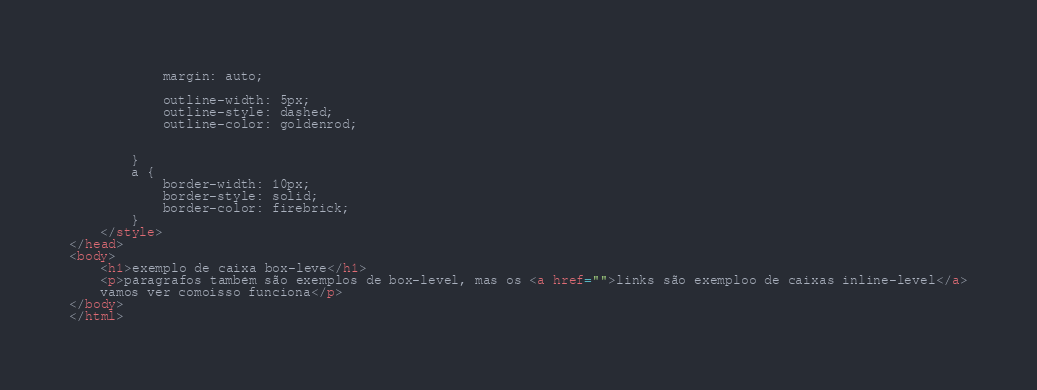Convert code to text. <code><loc_0><loc_0><loc_500><loc_500><_HTML_>            margin: auto;
            
            outline-width: 5px;
            outline-style: dashed;
            outline-color: goldenrod;


        }
        a {
            border-width: 10px;
            border-style: solid;
            border-color: firebrick;
        }
    </style>
</head>
<body>
    <h1>exemplo de caixa box-leve</h1>
    <p>páragrafos também são exemplos de box-level, mas os <a href="">links são exemploo de caixas inline-level</a>
    vamos ver comoisso funciona</p>
</body>
</html></code> 